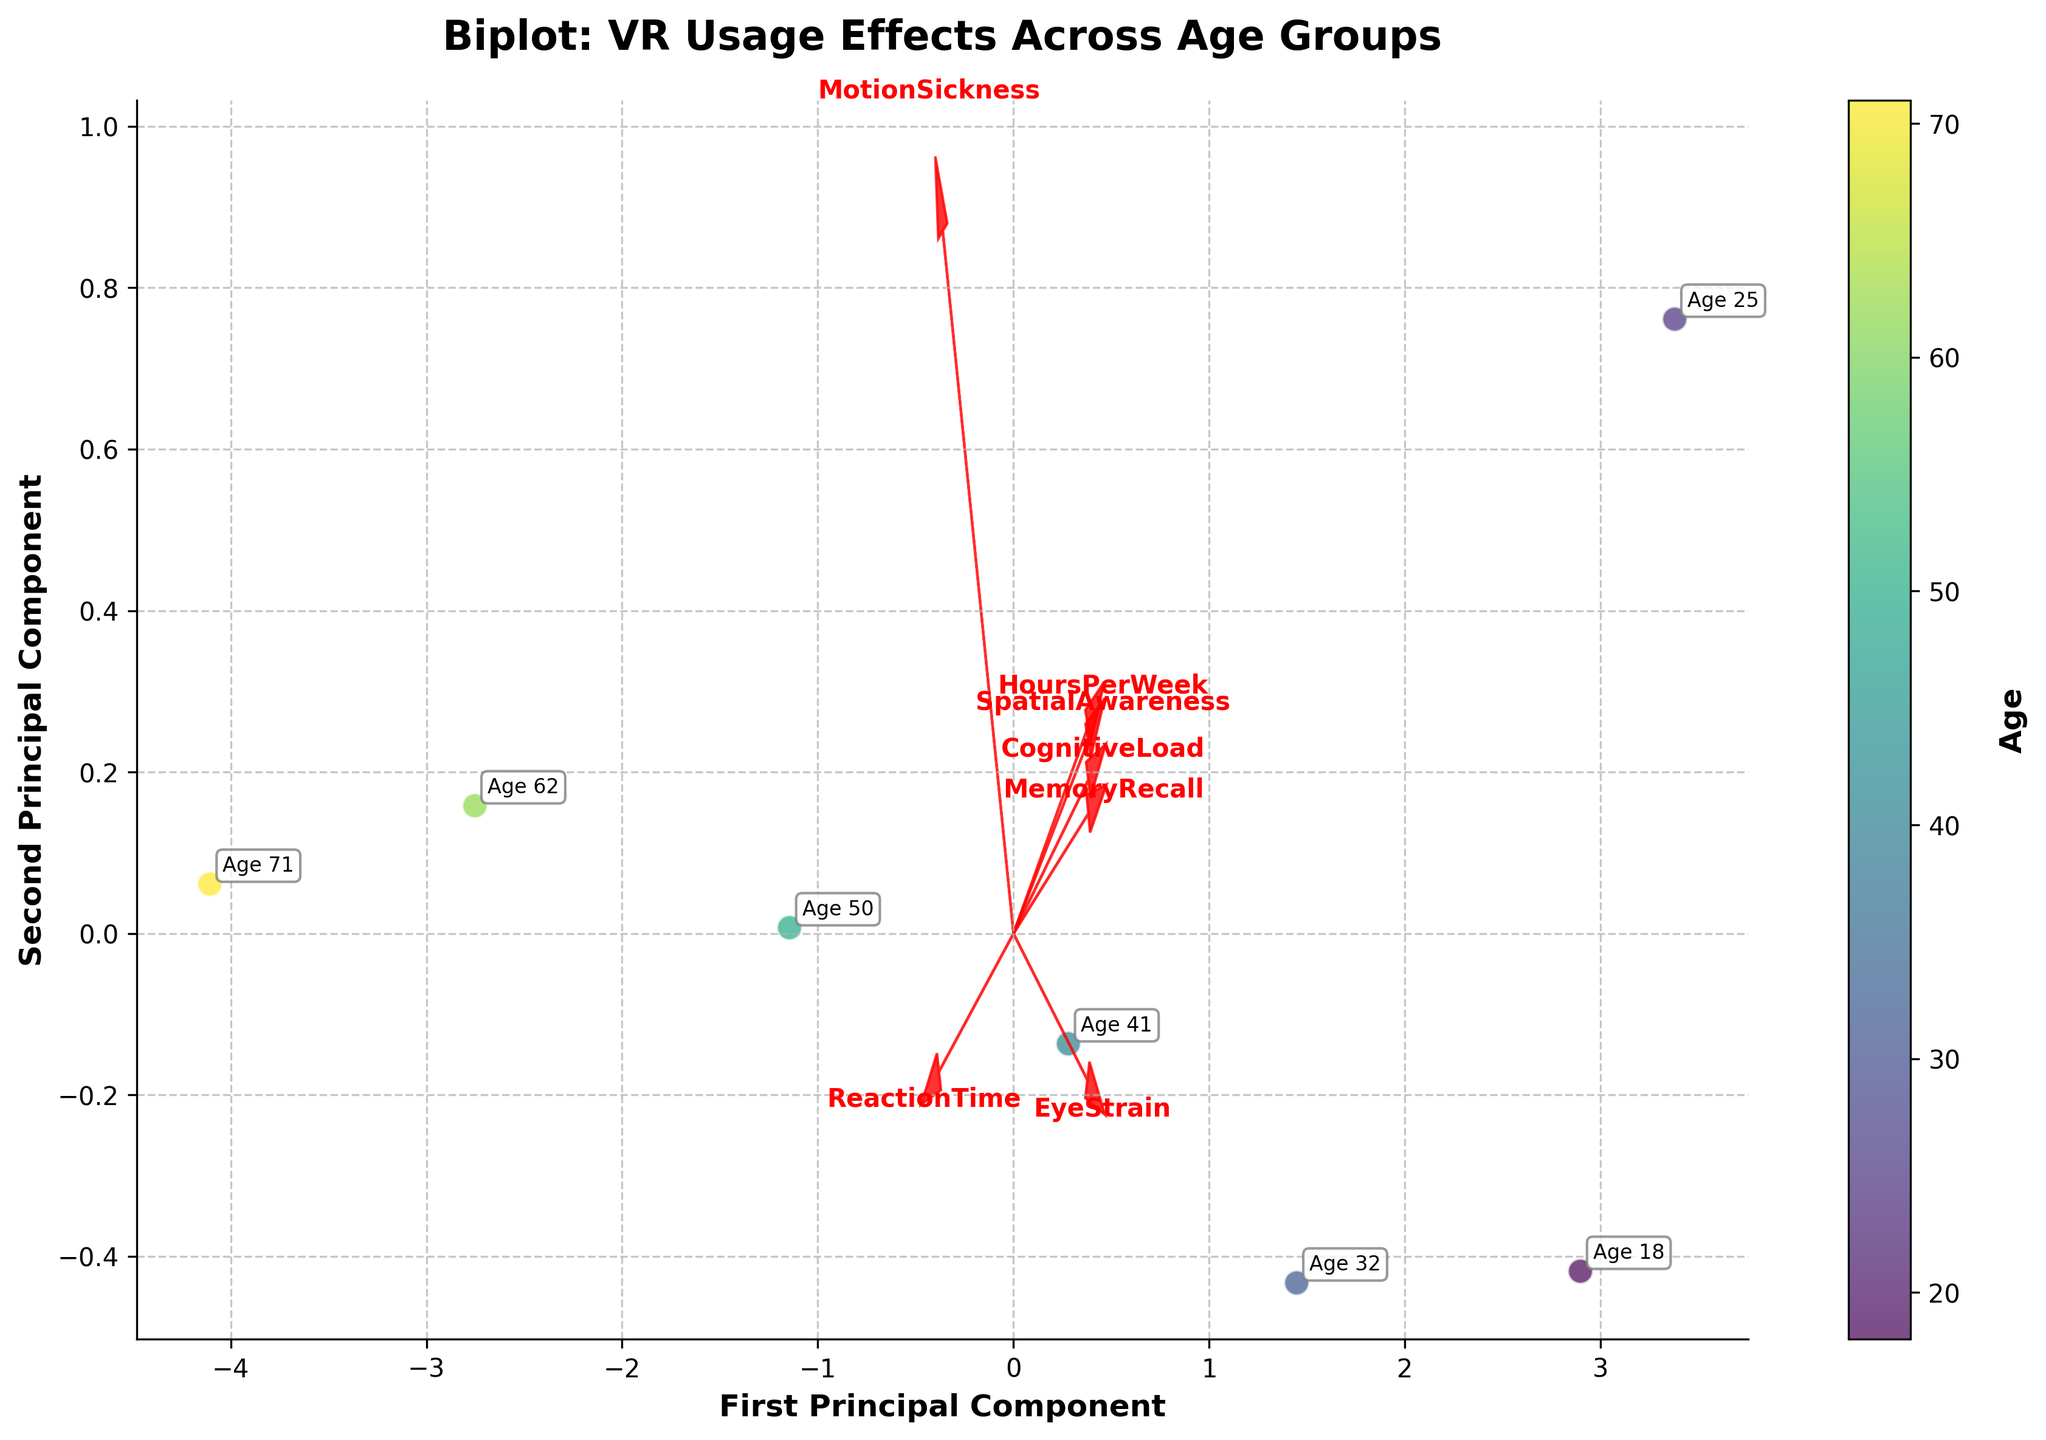What is the title of the Biplot? The title is displayed at the top of the figure in bold. Reading it directly, it states "Biplot: VR Usage Effects Across Age Groups."
Answer: Biplot: VR Usage Effects Across Age Groups How many age groups are represented in the figure? By counting the annotations or the unique colors on the plotted scatter points, we can see seven distinct age groups displayed.
Answer: Seven age groups Which feature vector has the highest contribution to the first principal component? Observe the lengths and directions of the feature vectors. The longest arrow pointing significantly in the horizontal direction on the figure indicates the feature contributing most to the first principal component.
Answer: HoursPerWeek Which two features seem to be most closely aligned in their effect on the first two principal components? Look for the feature vectors that are nearly parallel and closely aligned. "EyeStrain" and "MotionSickness" arrows seem to point in quite similar directions.
Answer: EyeStrain and MotionSickness What is the relationship between age and HoursPerWeek based on the plot? Notice where the plotted points (representing different ages) lie concerning the "HoursPerWeek" vector arrow. Younger age groups (lower values) are located towards the positive side of the "HoursPerWeek" vector, suggesting higher hours per week.
Answer: Younger age groups spend more hours per week in VR Which feature vector points most directly opposite to the SpatialAwareness vector? Observe the direction of the "SpatialAwareness" vector and identify the feature vector that points in the directly opposite direction, suggesting an inverse relationship.
Answer: ReactionTime How does the value of ReactionTime vary across age groups according to the plot? By following the "ReactionTime" vector, observe the placement of age groups along this direction. Older age groups tend towards the positive direction of this vector, while younger age groups are positioned towards the negative.
Answer: ReactionTime increases with age Which age group exhibits the highest cognitive load according to its positioning in the biplot? By locating the "CognitiveLoad" vector and finding which age group's point lies furthest out in its direction, we see the 25-year age group lies the furthest in that direction.
Answer: 25 years Between the age groups of 18 and 71, which one shows a lesser association with EyeStrain in the figure? Locate the points for ages 18 and 71 in the biplot and check their distance and direction relative to the "EyeStrain" vector. The 71-year age group is further from and less aligned with this vector.
Answer: 71 years What general trend do you observe for MemoryRecall as age increases from 18 to 71? Trace the "MemoryRecall" vector and notice how the plotted points progressively occupy more negative positions along this vector as age increases, indicating a decline.
Answer: MemoryRecall decreases with age 